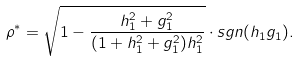<formula> <loc_0><loc_0><loc_500><loc_500>\rho ^ { * } = \sqrt { 1 - \frac { h _ { 1 } ^ { 2 } + g _ { 1 } ^ { 2 } } { ( 1 + h _ { 1 } ^ { 2 } + g _ { 1 } ^ { 2 } ) h _ { 1 } ^ { 2 } } } \cdot s g n ( h _ { 1 } g _ { 1 } ) .</formula> 